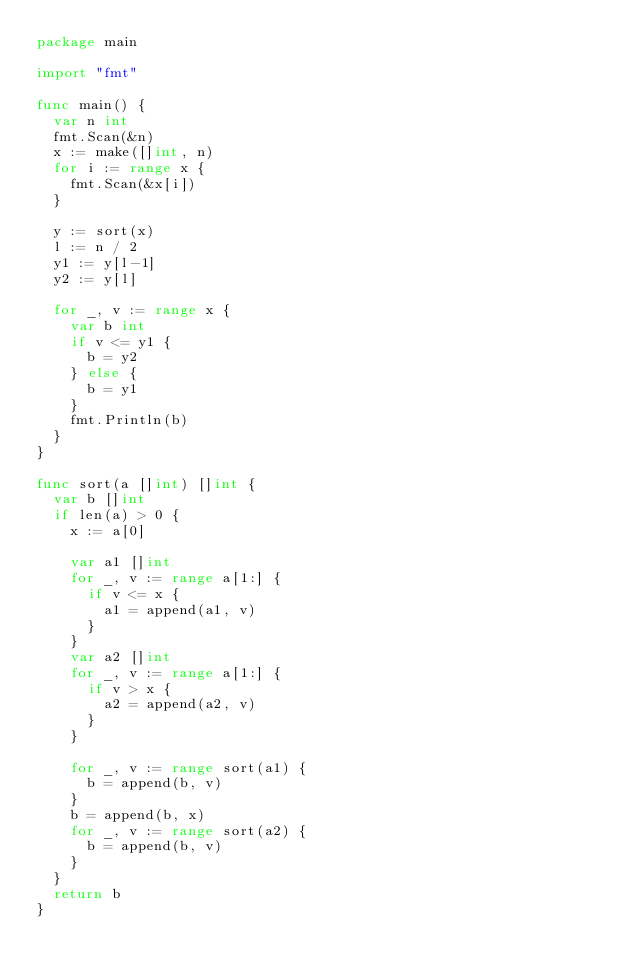Convert code to text. <code><loc_0><loc_0><loc_500><loc_500><_Go_>package main

import "fmt"

func main() {
	var n int
	fmt.Scan(&n)
	x := make([]int, n)
	for i := range x {
		fmt.Scan(&x[i])
	}

	y := sort(x)
	l := n / 2
	y1 := y[l-1]
	y2 := y[l]

	for _, v := range x {
		var b int
		if v <= y1 {
			b = y2
		} else {
			b = y1
		}
		fmt.Println(b)
	}
}

func sort(a []int) []int {
	var b []int
	if len(a) > 0 {
		x := a[0]

		var a1 []int
		for _, v := range a[1:] {
			if v <= x {
				a1 = append(a1, v)
			}
		}
		var a2 []int
		for _, v := range a[1:] {
			if v > x {
				a2 = append(a2, v)
			}
		}

		for _, v := range sort(a1) {
			b = append(b, v)
		}
		b = append(b, x)
		for _, v := range sort(a2) {
			b = append(b, v)
		}
	}
	return b
}
</code> 